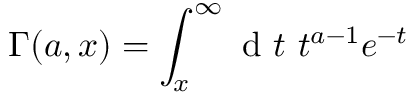<formula> <loc_0><loc_0><loc_500><loc_500>\Gamma ( a , x ) = \int _ { x } ^ { \infty } d t \ t ^ { a - 1 } e ^ { - t }</formula> 